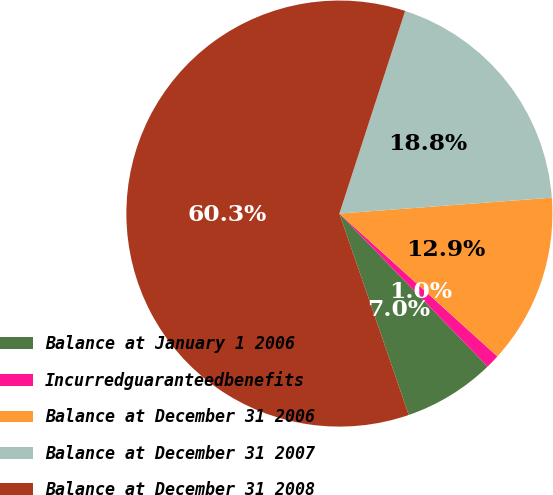Convert chart. <chart><loc_0><loc_0><loc_500><loc_500><pie_chart><fcel>Balance at January 1 2006<fcel>Incurredguaranteedbenefits<fcel>Balance at December 31 2006<fcel>Balance at December 31 2007<fcel>Balance at December 31 2008<nl><fcel>6.97%<fcel>1.05%<fcel>12.89%<fcel>18.82%<fcel>60.28%<nl></chart> 